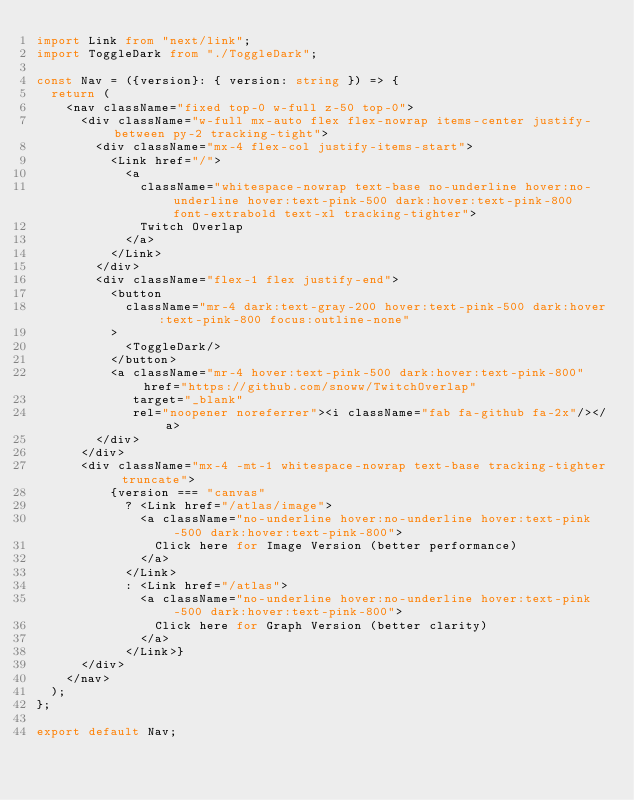<code> <loc_0><loc_0><loc_500><loc_500><_TypeScript_>import Link from "next/link";
import ToggleDark from "./ToggleDark";

const Nav = ({version}: { version: string }) => {
  return (
    <nav className="fixed top-0 w-full z-50 top-0">
      <div className="w-full mx-auto flex flex-nowrap items-center justify-between py-2 tracking-tight">
        <div className="mx-4 flex-col justify-items-start">
          <Link href="/">
            <a
              className="whitespace-nowrap text-base no-underline hover:no-underline hover:text-pink-500 dark:hover:text-pink-800 font-extrabold text-xl tracking-tighter">
              Twitch Overlap
            </a>
          </Link>
        </div>
        <div className="flex-1 flex justify-end">
          <button
            className="mr-4 dark:text-gray-200 hover:text-pink-500 dark:hover:text-pink-800 focus:outline-none"
          >
            <ToggleDark/>
          </button>
          <a className="mr-4 hover:text-pink-500 dark:hover:text-pink-800" href="https://github.com/snoww/TwitchOverlap"
             target="_blank"
             rel="noopener noreferrer"><i className="fab fa-github fa-2x"/></a>
        </div>
      </div>
      <div className="mx-4 -mt-1 whitespace-nowrap text-base tracking-tighter truncate">
          {version === "canvas"
            ? <Link href="/atlas/image">
              <a className="no-underline hover:no-underline hover:text-pink-500 dark:hover:text-pink-800">
                Click here for Image Version (better performance)
              </a>
            </Link>
            : <Link href="/atlas">
              <a className="no-underline hover:no-underline hover:text-pink-500 dark:hover:text-pink-800">
                Click here for Graph Version (better clarity)
              </a>
            </Link>}
      </div>
    </nav>
  );
};

export default Nav;
</code> 